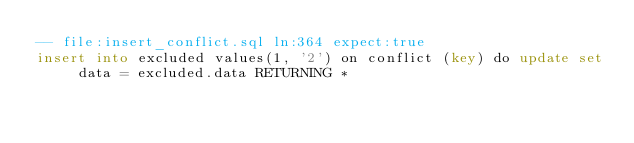Convert code to text. <code><loc_0><loc_0><loc_500><loc_500><_SQL_>-- file:insert_conflict.sql ln:364 expect:true
insert into excluded values(1, '2') on conflict (key) do update set data = excluded.data RETURNING *
</code> 